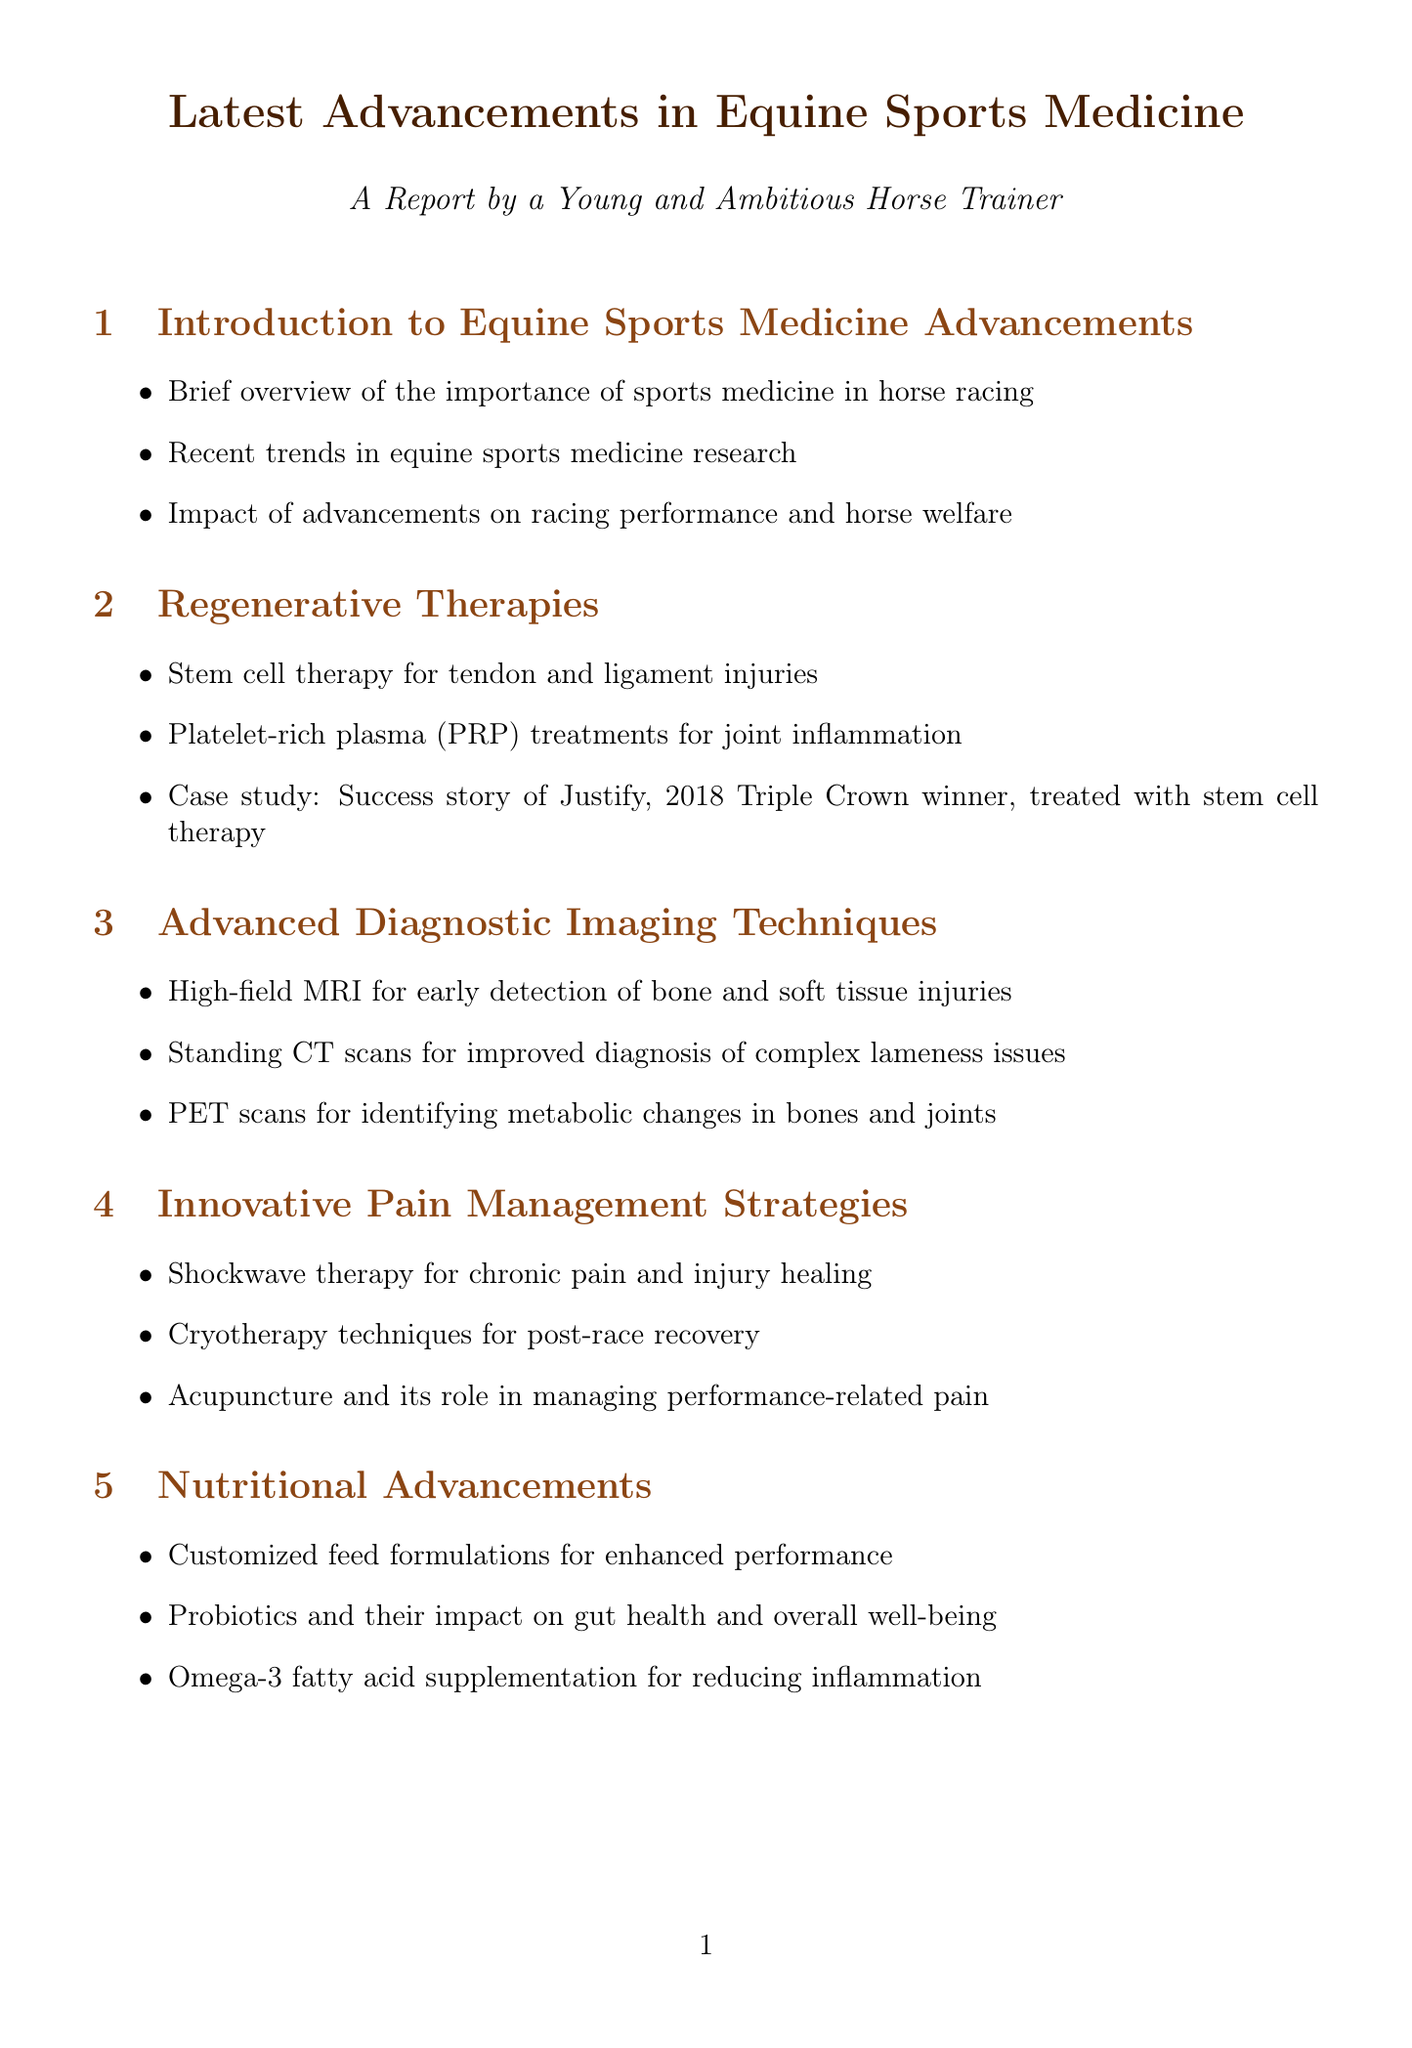What is the title of the report? The title of the report is stated at the beginning and is "Latest Advancements in Equine Sports Medicine."
Answer: Latest Advancements in Equine Sports Medicine Who is the leading researcher in stem cell therapy for tendon injuries? The document lists Dr. Lisa Fortier as the leading researcher in this area.
Answer: Dr. Lisa Fortier What percentage reduction in career-ending injuries has been reported since 2010? The report includes a statistic stating a 30% reduction in career-ending injuries.
Answer: 30% What treatment did the 2018 Triple Crown winner, Justify, receive? The case study mentions that Justify was treated with stem cell therapy.
Answer: Stem cell therapy Which advanced diagnostic imaging technique is used for early detection of bone injuries? The report outlines that high-field MRI is used for early detection of such injuries.
Answer: High-field MRI In what year did American Pharoah win the Triple Crown? The document states that American Pharoah became a Triple Crown winner in 2015.
Answer: 2015 What type of technology is used for real-time performance data tracking? The document specifies that GPS-enabled tracking systems are used for this purpose.
Answer: GPS-enabled tracking systems What is a key focus of the future directions section in the report? The future directions section discusses emerging research in gene therapy for performance enhancement.
Answer: Gene therapy for performance enhancement 